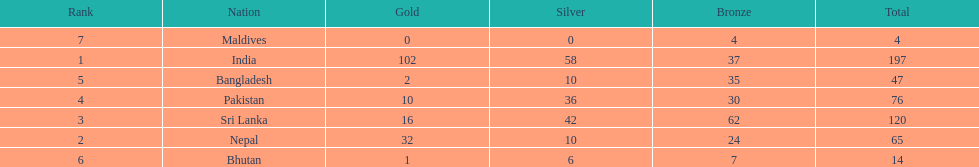What was the number of silver medals won by pakistan? 36. 